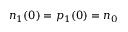Convert formula to latex. <formula><loc_0><loc_0><loc_500><loc_500>n _ { 1 } ( 0 ) = p _ { 1 } ( 0 ) = n _ { 0 }</formula> 